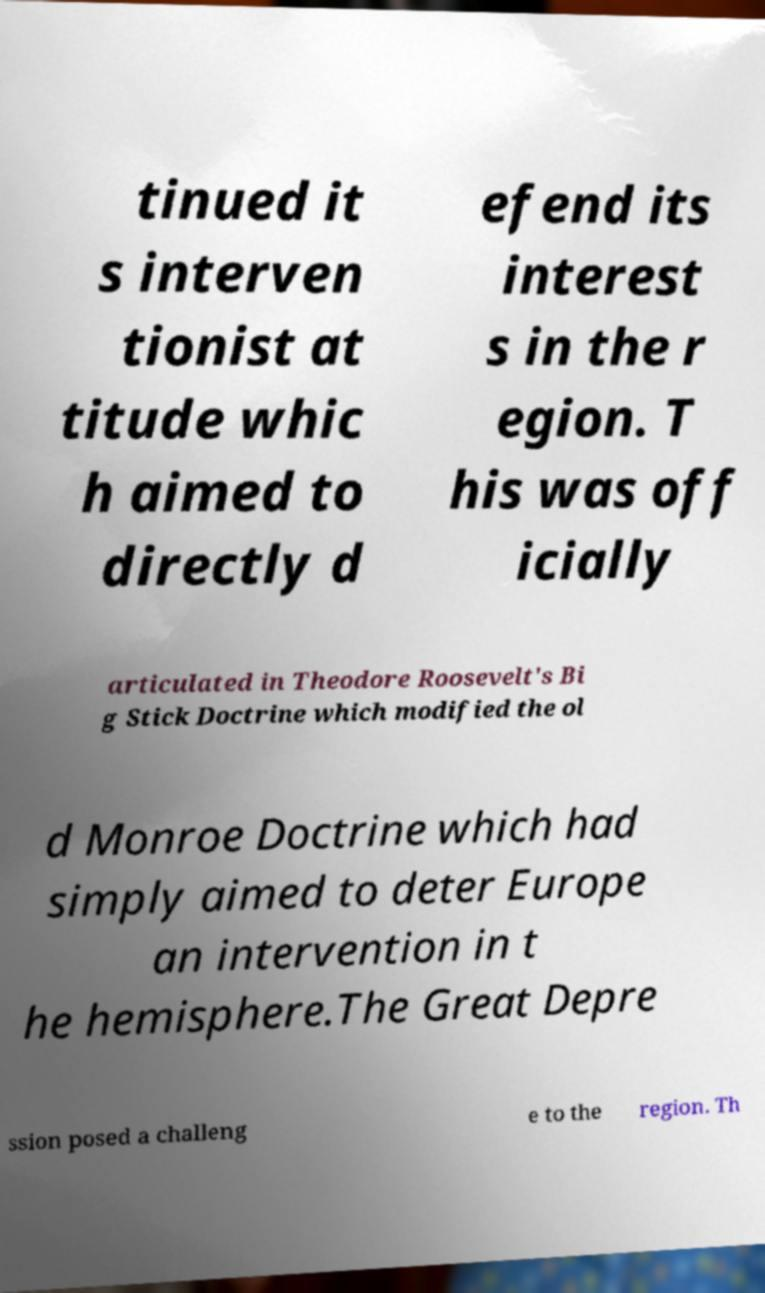Can you read and provide the text displayed in the image?This photo seems to have some interesting text. Can you extract and type it out for me? tinued it s interven tionist at titude whic h aimed to directly d efend its interest s in the r egion. T his was off icially articulated in Theodore Roosevelt's Bi g Stick Doctrine which modified the ol d Monroe Doctrine which had simply aimed to deter Europe an intervention in t he hemisphere.The Great Depre ssion posed a challeng e to the region. Th 